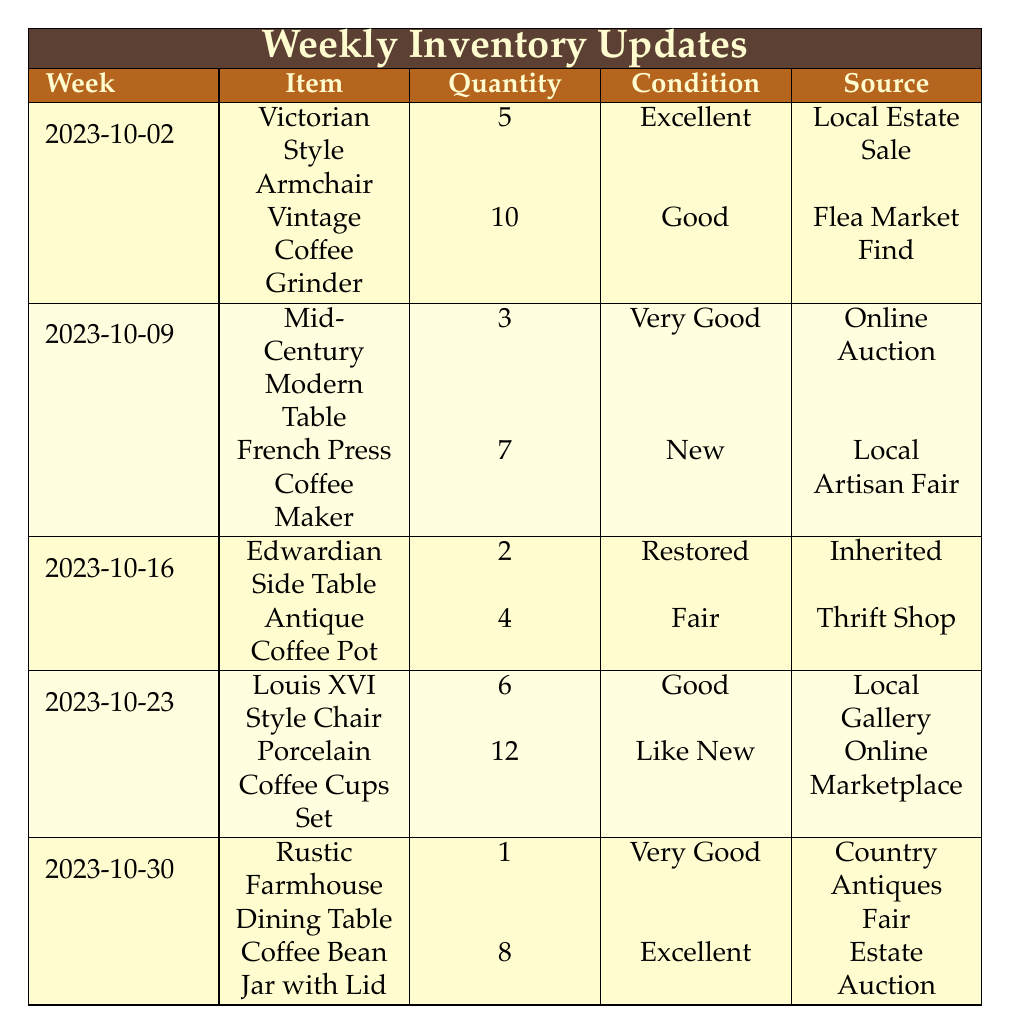What is the condition of the Victorian Style Armchair? The 'Victorian Style Armchair' is listed under the week of 2023-10-02, and the condition is indicated as 'Excellent' in the table.
Answer: Excellent How many Vintage Coffee Grinders are available? From the same entry for the week of 2023-10-02, the quantity of 'Vintage Coffee Grinder' is 10, as stated in the table.
Answer: 10 Which week had the highest quantity of coffee-related decor items? To find the highest quantity of coffee-related decor items, we check the quantities across all weeks for coffee items. The maximum is 12 for 'Porcelain Coffee Cups Set' in the week of 2023-10-23.
Answer: 2023-10-23 How many total coffee-related decor items are in the inventory? Adding up all the quantities of coffee-related decor items gives: 10 (Vintage Coffee Grinder) + 7 (French Press Coffee Maker) + 4 (Antique Coffee Pot) + 12 (Porcelain Coffee Cups Set) + 8 (Coffee Bean Jar with Lid) = 41 total items.
Answer: 41 Is there an item in 'Good' condition in the week of 2023-10-09? In the week of 2023-10-09, the 'Mid-Century Modern Table' is listed as 'Very Good,' and the 'French Press Coffee Maker' is 'New,' thus there are no items marked as 'Good'.
Answer: No What is the total quantity of Antique Furniture items listed in the entire table? To find the total quantity of Antique Furniture, we sum them up: 5 (Victorian Style Armchair) + 3 (Mid-Century Modern Table) + 2 (Edwardian Side Table) + 6 (Louis XVI Style Chair) + 1 (Rustic Farmhouse Dining Table) = 17.
Answer: 17 Are there any items listed as 'Like New'? The week of 2023-10-23 has 'Porcelain Coffee Cups Set' listed as 'Like New'. Therefore, the answer is yes.
Answer: Yes What is the average quantity of Coffee-Related Decor items across the weeks? The quantities for coffee-related decor are 10, 7, 4, 12, and 8. The sum is 41. There are 5 weeks, so the average is 41 / 5 = 8.2.
Answer: 8.2 